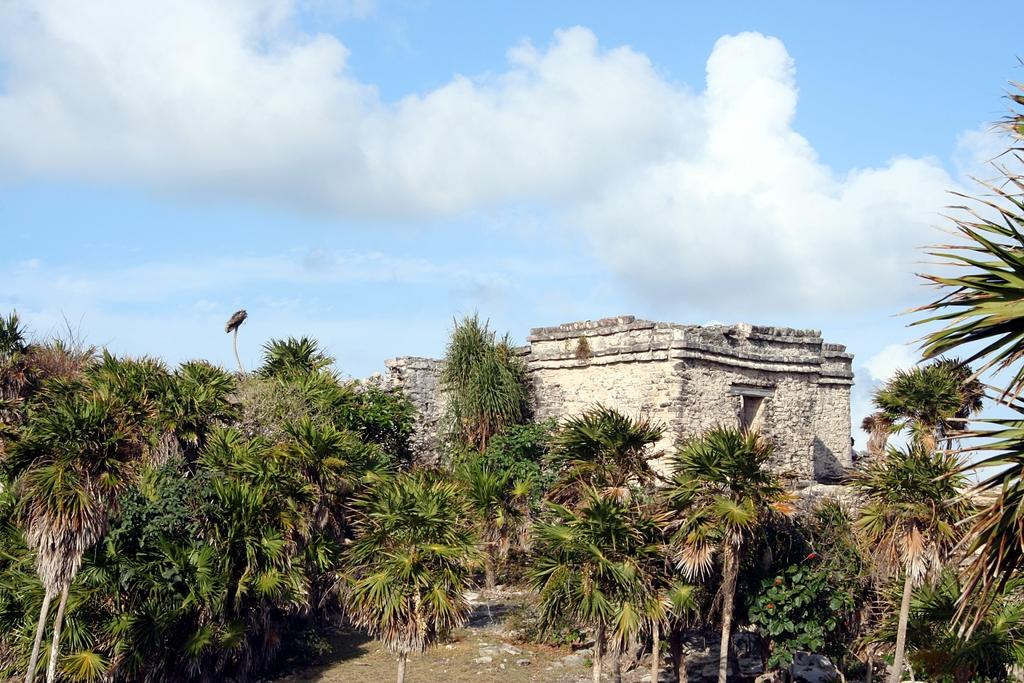What type of vegetation is at the bottom of the picture? There are trees at the bottom of the picture. What is located behind the trees in the picture? There is a building made up of stones behind the trees. What can be seen at the top of the picture? The sky is visible at the top of the picture. What is present in the sky? Clouds are present in the sky. Where is the frame of the picture located? The frame of the picture is not visible in the image itself, as it is the physical border around the image. What type of furniture is present in the picture? There is no furniture present in the image; it features trees, a stone building, and the sky. 